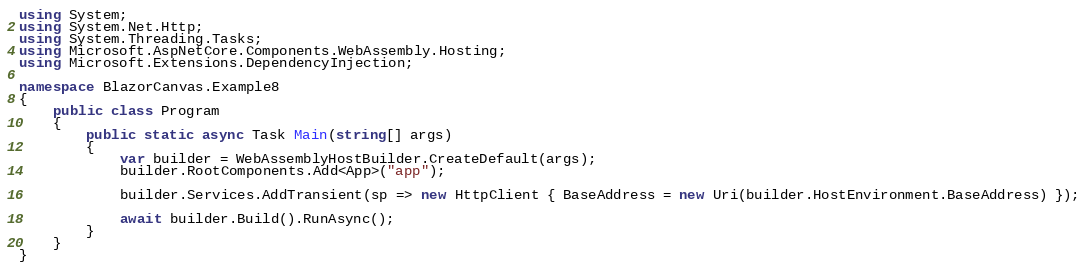Convert code to text. <code><loc_0><loc_0><loc_500><loc_500><_C#_>using System;
using System.Net.Http;
using System.Threading.Tasks;
using Microsoft.AspNetCore.Components.WebAssembly.Hosting;
using Microsoft.Extensions.DependencyInjection;

namespace BlazorCanvas.Example8
{
    public class Program
    {
        public static async Task Main(string[] args)
        {
            var builder = WebAssemblyHostBuilder.CreateDefault(args);
            builder.RootComponents.Add<App>("app");

            builder.Services.AddTransient(sp => new HttpClient { BaseAddress = new Uri(builder.HostEnvironment.BaseAddress) });

            await builder.Build().RunAsync();
        }
    }
}
</code> 